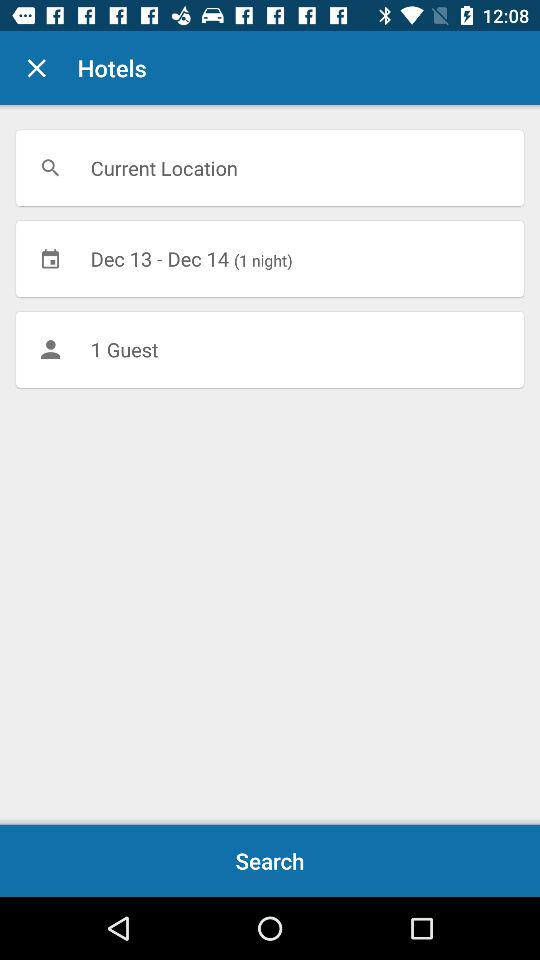How many guests are there? There is 1 guest. 